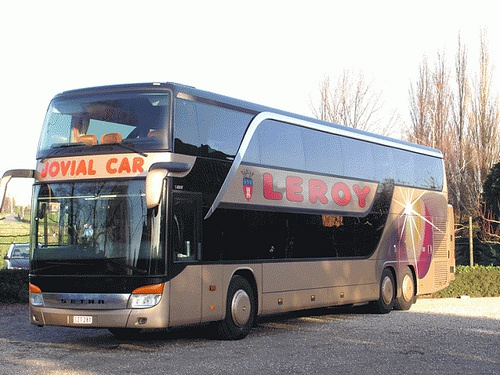Describe the objects in this image and their specific colors. I can see bus in white, black, gray, and darkgray tones and car in white, gray, and darkgray tones in this image. 